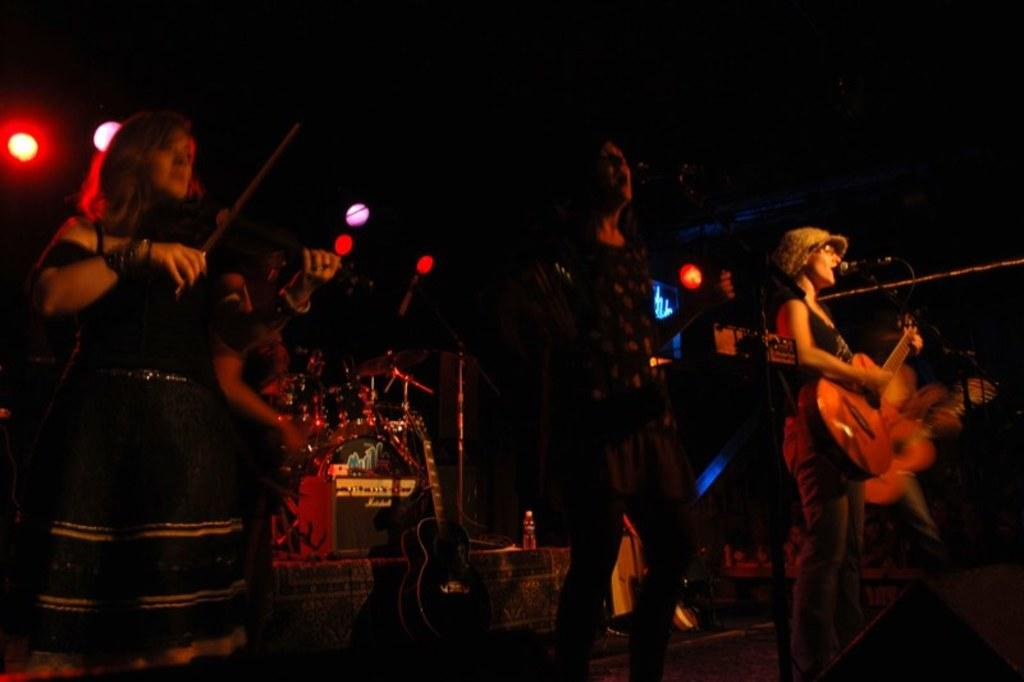What is happening on the stage in the image? There is an orchestra on the stage in the image. What can be seen above the stage in the image? There are lights over the ceiling in the image. What is the distance between the moon and the stage in the image? The moon is not present in the image, so it is not possible to determine the distance between the moon and the stage. 